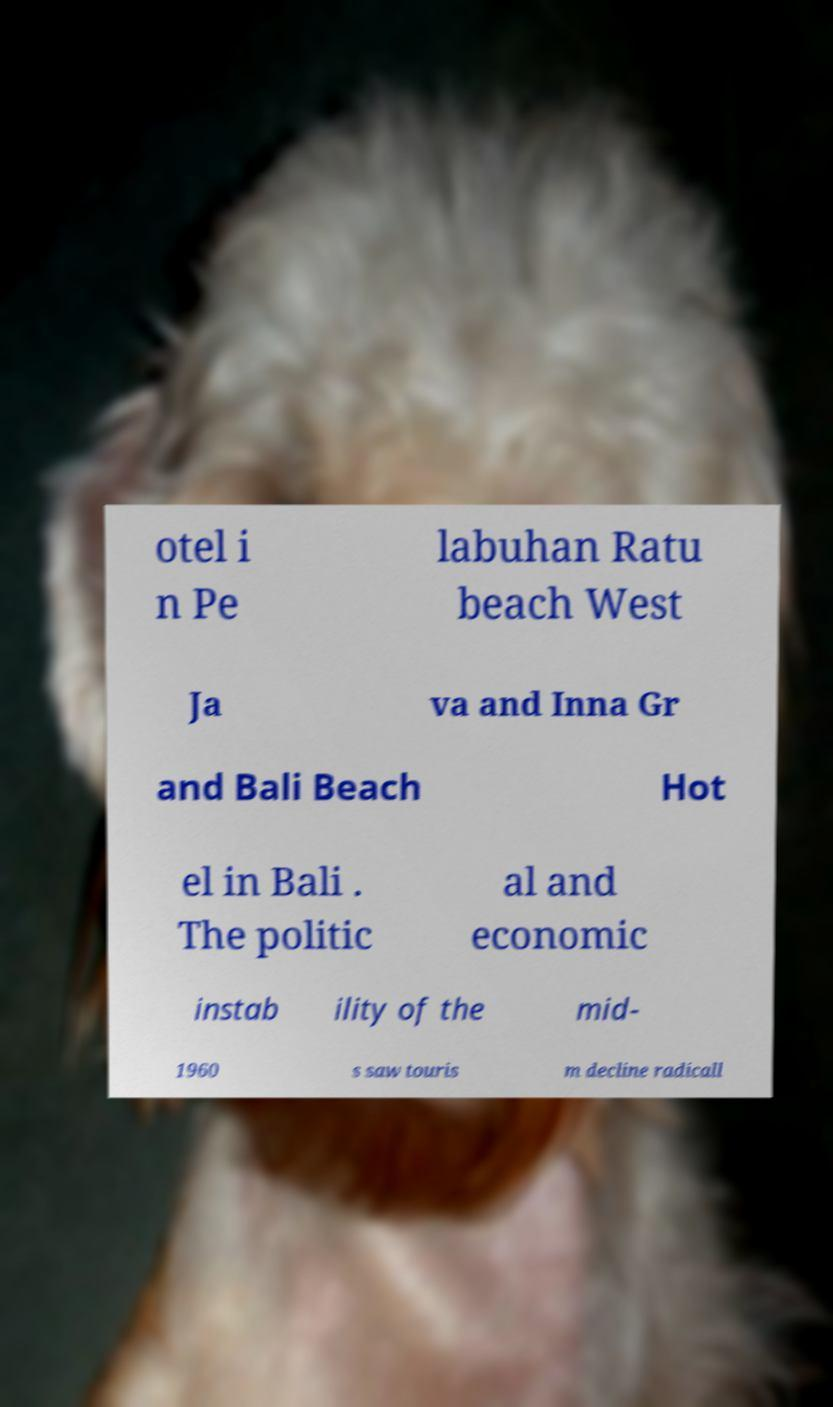Could you extract and type out the text from this image? otel i n Pe labuhan Ratu beach West Ja va and Inna Gr and Bali Beach Hot el in Bali . The politic al and economic instab ility of the mid- 1960 s saw touris m decline radicall 